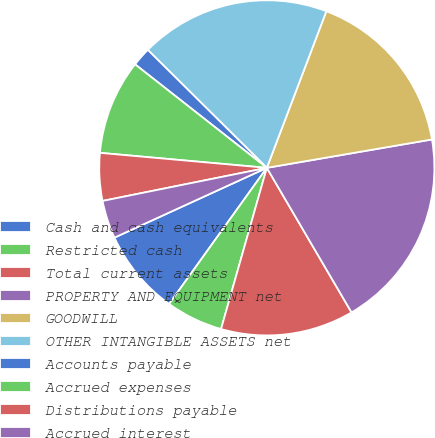Convert chart to OTSL. <chart><loc_0><loc_0><loc_500><loc_500><pie_chart><fcel>Cash and cash equivalents<fcel>Restricted cash<fcel>Total current assets<fcel>PROPERTY AND EQUIPMENT net<fcel>GOODWILL<fcel>OTHER INTANGIBLE ASSETS net<fcel>Accounts payable<fcel>Accrued expenses<fcel>Distributions payable<fcel>Accrued interest<nl><fcel>8.26%<fcel>5.5%<fcel>12.84%<fcel>19.27%<fcel>16.51%<fcel>18.35%<fcel>1.83%<fcel>9.17%<fcel>4.59%<fcel>3.67%<nl></chart> 